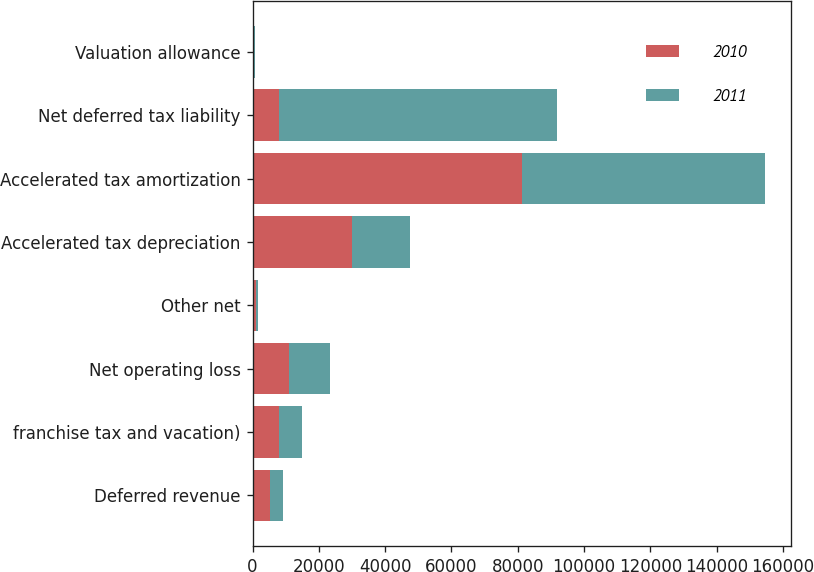Convert chart. <chart><loc_0><loc_0><loc_500><loc_500><stacked_bar_chart><ecel><fcel>Deferred revenue<fcel>franchise tax and vacation)<fcel>Net operating loss<fcel>Other net<fcel>Accelerated tax depreciation<fcel>Accelerated tax amortization<fcel>Net deferred tax liability<fcel>Valuation allowance<nl><fcel>2010<fcel>5372<fcel>8086<fcel>11097<fcel>1122<fcel>29971<fcel>81265<fcel>8086<fcel>306<nl><fcel>2011<fcel>3875<fcel>6730<fcel>12222<fcel>514<fcel>17425<fcel>73355<fcel>83746<fcel>306<nl></chart> 